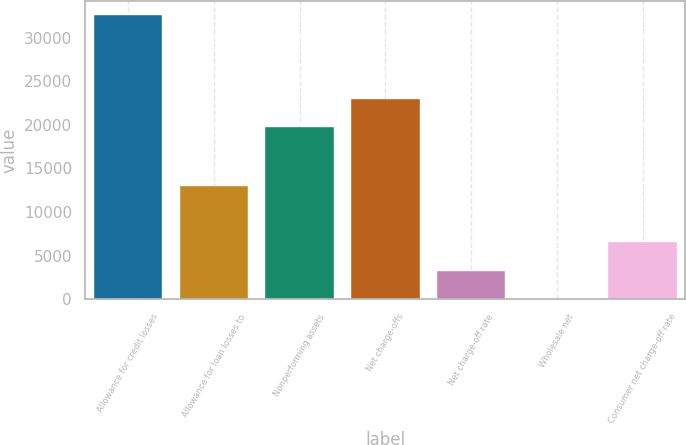Convert chart to OTSL. <chart><loc_0><loc_0><loc_500><loc_500><bar_chart><fcel>Allowance for credit losses<fcel>Allowance for loan losses to<fcel>Nonperforming assets<fcel>Net charge-offs<fcel>Net charge-off rate<fcel>Wholesale net<fcel>Consumer net charge-off rate<nl><fcel>32541<fcel>13017.2<fcel>19741<fcel>22995<fcel>3255.36<fcel>1.4<fcel>6509.32<nl></chart> 